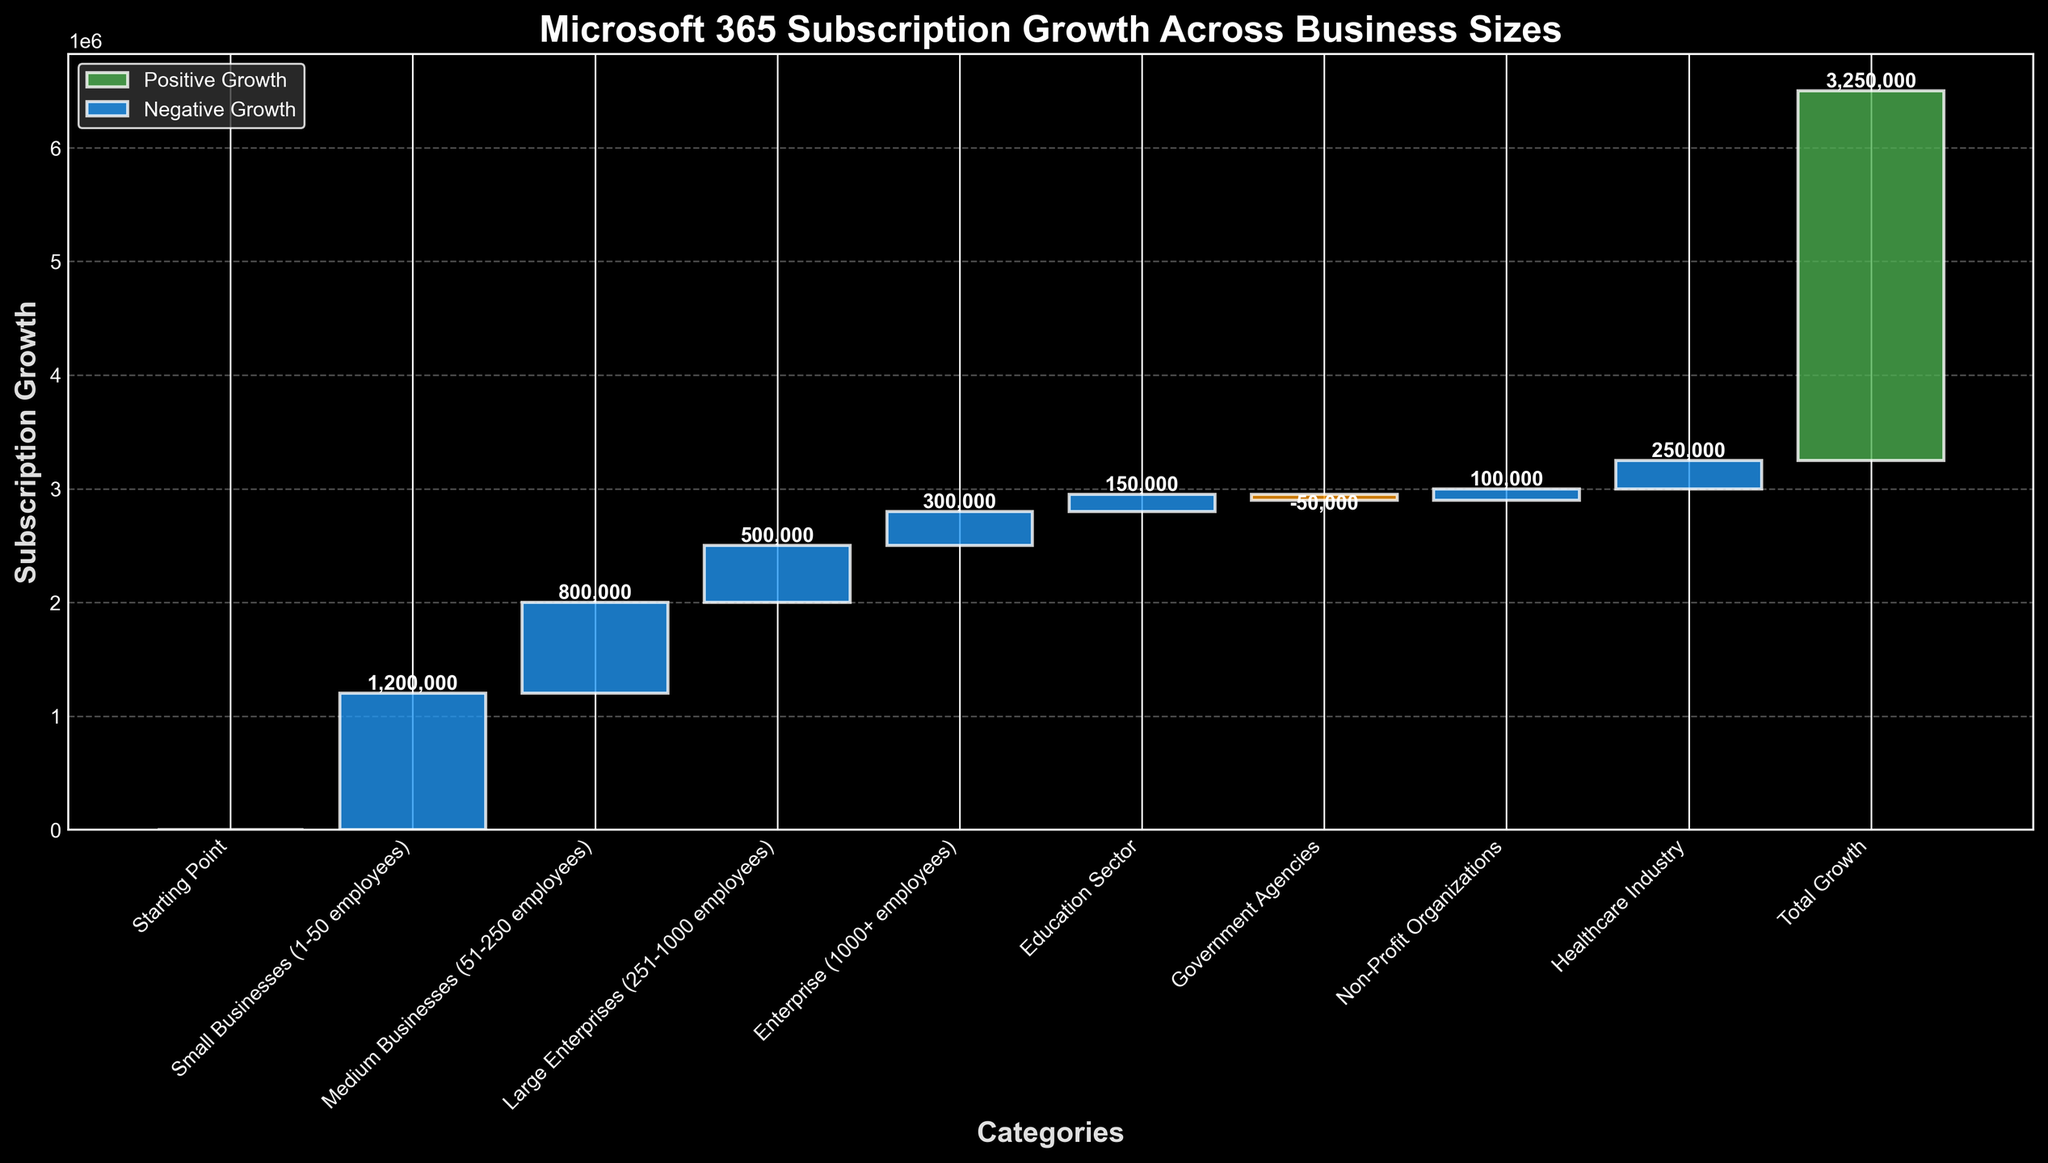What is the title of the figure? The title is usually displayed at the top of the figure. Here, the title reads "Microsoft 365 Subscription Growth Across Business Sizes" in a larger and bold font.
Answer: Microsoft 365 Subscription Growth Across Business Sizes Which category has the highest subscription growth? By looking at the height of the bars, the tallest green bar is under the category "Small Businesses (1-50 employees)" which represents the highest growth.
Answer: Small Businesses (1-50 employees) What is the total subscription growth? The "Total Growth" category at the end of the chart represents the sum of all contributions. The cumulative total shown is 3,250,000.
Answer: 3,250,000 How does the subscription growth for Small Businesses compare to Medium Businesses? The value for Small Businesses (1-50 employees) is 1,200,000, while for Medium Businesses (51-250 employees) it is 800,000. 1,200,000 is greater than 800,000.
Answer: Small Businesses (1-50 employees) > Medium Businesses (51-250 employees) What is the net growth for sectors with positive contributions? Sum the positive growth values: 1,200,000 (Small Businesses) + 800,000 (Medium Businesses) + 500,000 (Large Enterprises) + 300,000 (Enterprise) + 150,000 (Education) + 100,000 (Non-Profit) + 250,000 (Healthcare). The total is 3,300,000.
Answer: 3,300,000 Which category has a negative growth, and what is its value? The negative bar (colored differently) represents "Government Agencies" with a value of -50,000.
Answer: Government Agencies, -50,000 Which two categories have a combined growth of 400,000? Looking at the values, the combination of "Large Enterprises (251-1000 employees)" with 500,000 and "Government Agencies" with -50,000 equals 450,000. Adjust to find another combination: "Education Sector" with 150,000 and "Healthcare Industry" with 250,000 sums to 400,000.
Answer: Education Sector and Healthcare Industry What is the percentage contribution of Large Enterprises (251-1000 employees) to the total growth? The value for Large Enterprises is 500,000. Divide this by the total growth (3,250,000) then multiply by 100 to get the percentage: (500,000 / 3,250,000) * 100 ≈ 15.38%.
Answer: ≈ 15.38% Which category contributed to bridging the gap between 2,000,000 and 2,500,000 cumulative growth? By examining the cumulative values, "Enterprise (1000+ employees)" bridges the gap from 2,020,000 to 2,320,000.
Answer: Enterprise (1000+ employees) What is the cumulative value just before the contribution from Non-Profit Organizations? The cumulative value before Non-Profit Organizations is the sum of all prior values: 0 (start) + 1,200,000 + 800,000 + 500,000 + 300,000 + 150,000 = 2,950,000.
Answer: 2,950,000 